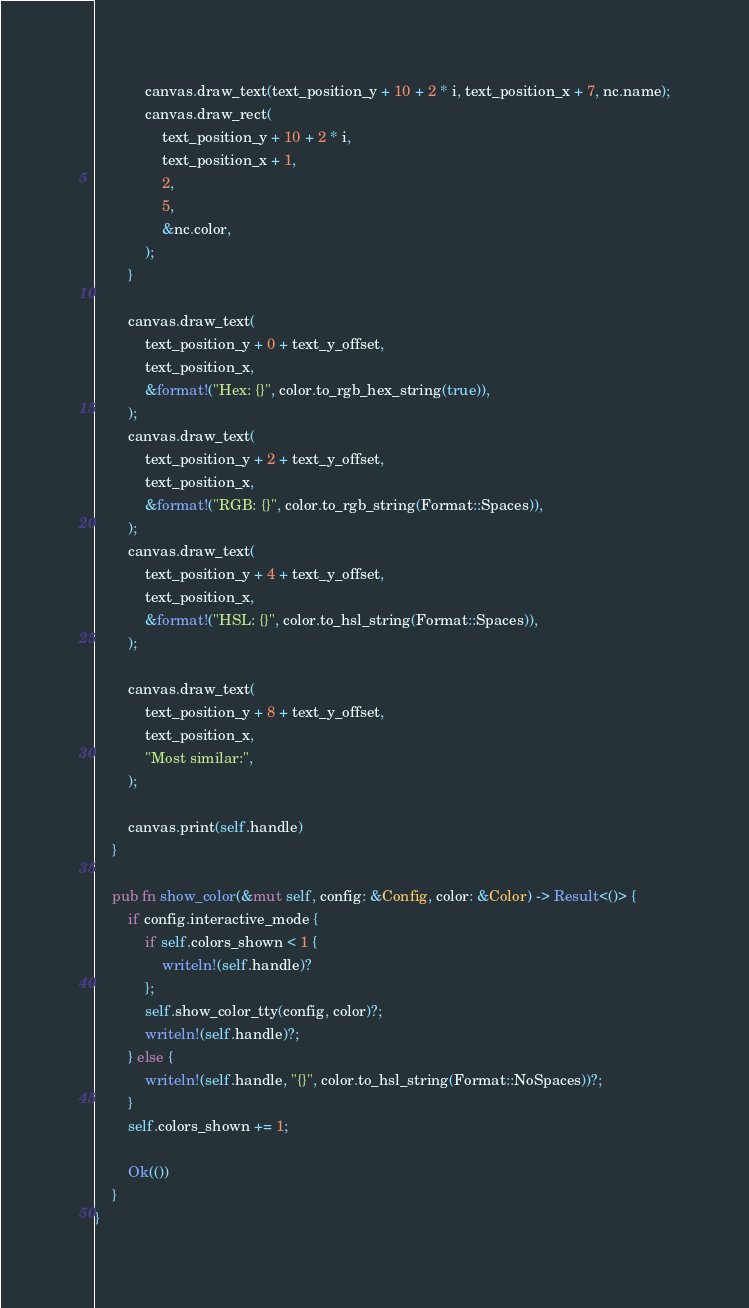<code> <loc_0><loc_0><loc_500><loc_500><_Rust_>
            canvas.draw_text(text_position_y + 10 + 2 * i, text_position_x + 7, nc.name);
            canvas.draw_rect(
                text_position_y + 10 + 2 * i,
                text_position_x + 1,
                2,
                5,
                &nc.color,
            );
        }

        canvas.draw_text(
            text_position_y + 0 + text_y_offset,
            text_position_x,
            &format!("Hex: {}", color.to_rgb_hex_string(true)),
        );
        canvas.draw_text(
            text_position_y + 2 + text_y_offset,
            text_position_x,
            &format!("RGB: {}", color.to_rgb_string(Format::Spaces)),
        );
        canvas.draw_text(
            text_position_y + 4 + text_y_offset,
            text_position_x,
            &format!("HSL: {}", color.to_hsl_string(Format::Spaces)),
        );

        canvas.draw_text(
            text_position_y + 8 + text_y_offset,
            text_position_x,
            "Most similar:",
        );

        canvas.print(self.handle)
    }

    pub fn show_color(&mut self, config: &Config, color: &Color) -> Result<()> {
        if config.interactive_mode {
            if self.colors_shown < 1 {
                writeln!(self.handle)?
            };
            self.show_color_tty(config, color)?;
            writeln!(self.handle)?;
        } else {
            writeln!(self.handle, "{}", color.to_hsl_string(Format::NoSpaces))?;
        }
        self.colors_shown += 1;

        Ok(())
    }
}
</code> 